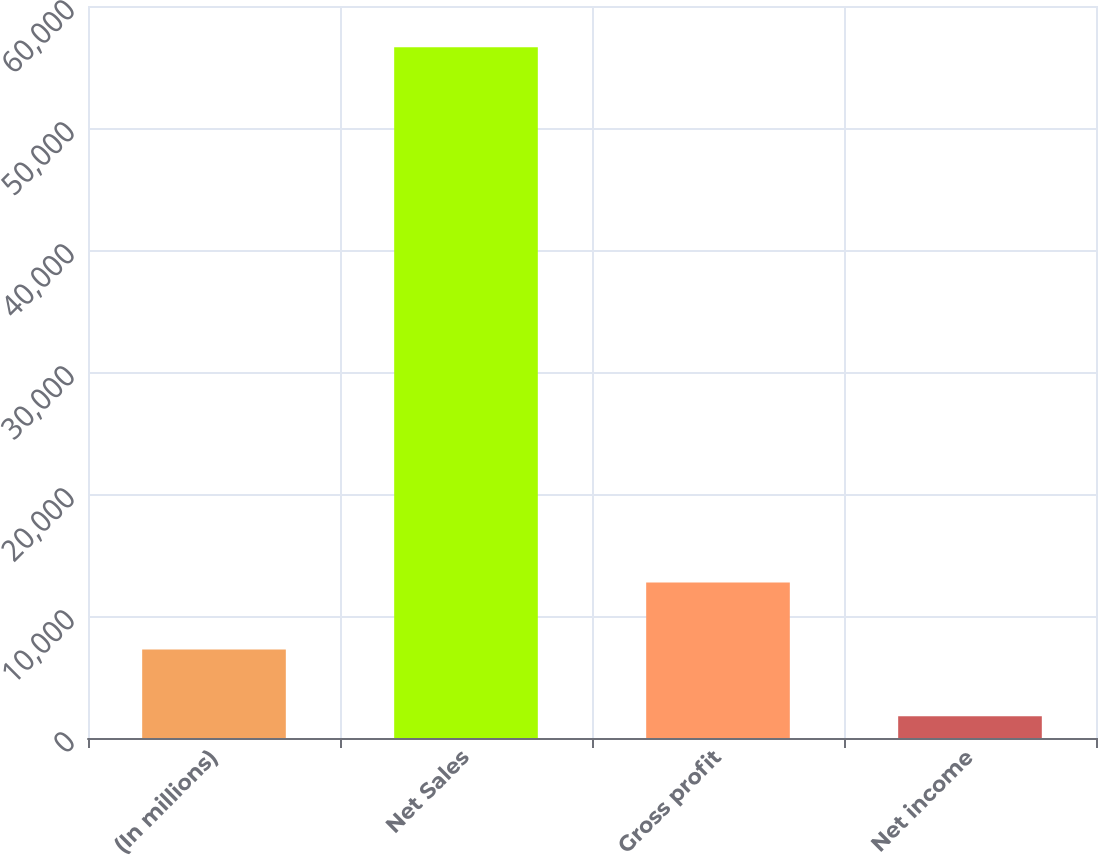<chart> <loc_0><loc_0><loc_500><loc_500><bar_chart><fcel>(In millions)<fcel>Net Sales<fcel>Gross profit<fcel>Net income<nl><fcel>7257.2<fcel>56615<fcel>12741.4<fcel>1773<nl></chart> 